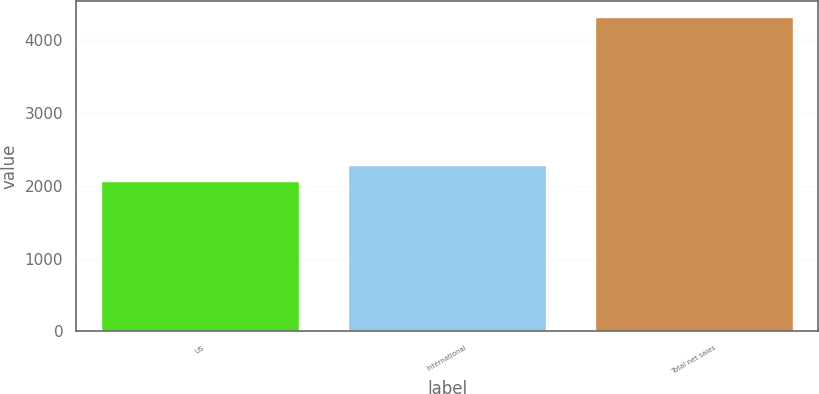<chart> <loc_0><loc_0><loc_500><loc_500><bar_chart><fcel>US<fcel>International<fcel>Total net sales<nl><fcel>2066.3<fcel>2292.46<fcel>4327.9<nl></chart> 